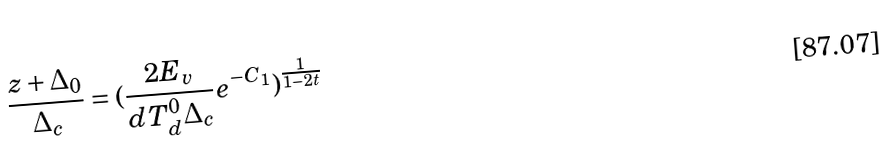<formula> <loc_0><loc_0><loc_500><loc_500>\frac { z + \Delta _ { 0 } } { \Delta _ { c } } = ( \frac { 2 E _ { v } } { d T _ { d } ^ { 0 } \Delta _ { c } } e ^ { - C _ { 1 } } ) ^ { \frac { 1 } { 1 - 2 t } }</formula> 